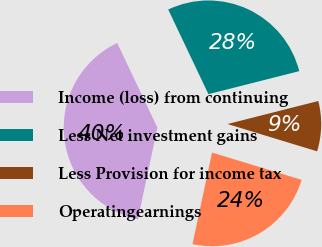<chart> <loc_0><loc_0><loc_500><loc_500><pie_chart><fcel>Income (loss) from continuing<fcel>Less Net investment gains<fcel>Less Provision for income tax<fcel>Operatingearnings<nl><fcel>39.6%<fcel>28.11%<fcel>8.66%<fcel>23.63%<nl></chart> 